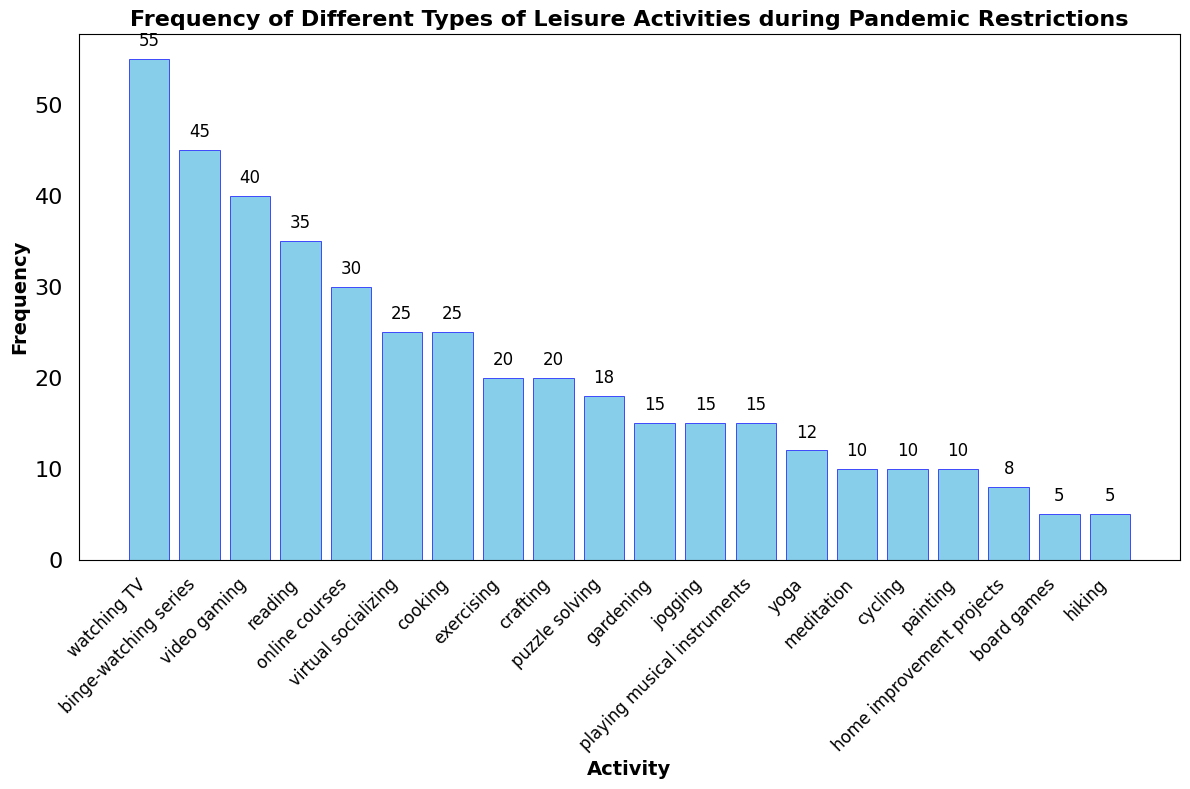What is the most frequently engaged leisure activity? The bar with the highest value represents the activity engaged in the most frequently. By inspection, the tallest bar corresponds to watching TV, with a frequency of 55.
Answer: Watching TV Which activity has a lower frequency: cycling or jogging? By examining the heights of the bars corresponding to cycling and jogging, cycling has a frequency of 10, and jogging has a frequency of 15. Since 10 is less than 15, cycling has a lower frequency.
Answer: Cycling What is the total frequency of reading, exercising, and cooking combined? By adding the frequencies of reading (35), exercising (20), and cooking (25): 35 + 20 + 25 = 80.
Answer: 80 Which activities have the same frequency? By scanning for bars of equal height, we see that gardening, jogging, playing musical instruments, and puzzle solving all have a frequency of 15.
Answer: Gardening, jogging, playing musical instruments, puzzle solving What is the sum of the frequencies of the three least engaged activities? The three lowest frequencies are for hiking (5), board games (5), and home improvement projects (8). Adding these: 5 + 5 + 8 = 18.
Answer: 18 Which activity has a frequency of 40? The bar with a frequency of 40 corresponds to video gaming.
Answer: Video gaming What's the difference in frequency between binge-watching series and virtual socializing? The frequencies for binge-watching series and virtual socializing are 45 and 25, respectively. The difference is 45 - 25 = 20.
Answer: 20 What is the average frequency of exercising, crafting, and puzzle solving? The frequencies are 20 for exercising, 20 for crafting, and 18 for puzzle solving. The average is (20 + 20 + 18) / 3 = 19.33.
Answer: 19.33 Which activity appears most infrequently on the diagram? The shortest bar represents the least frequent activity, which is board games with a frequency of 5.
Answer: Board games 